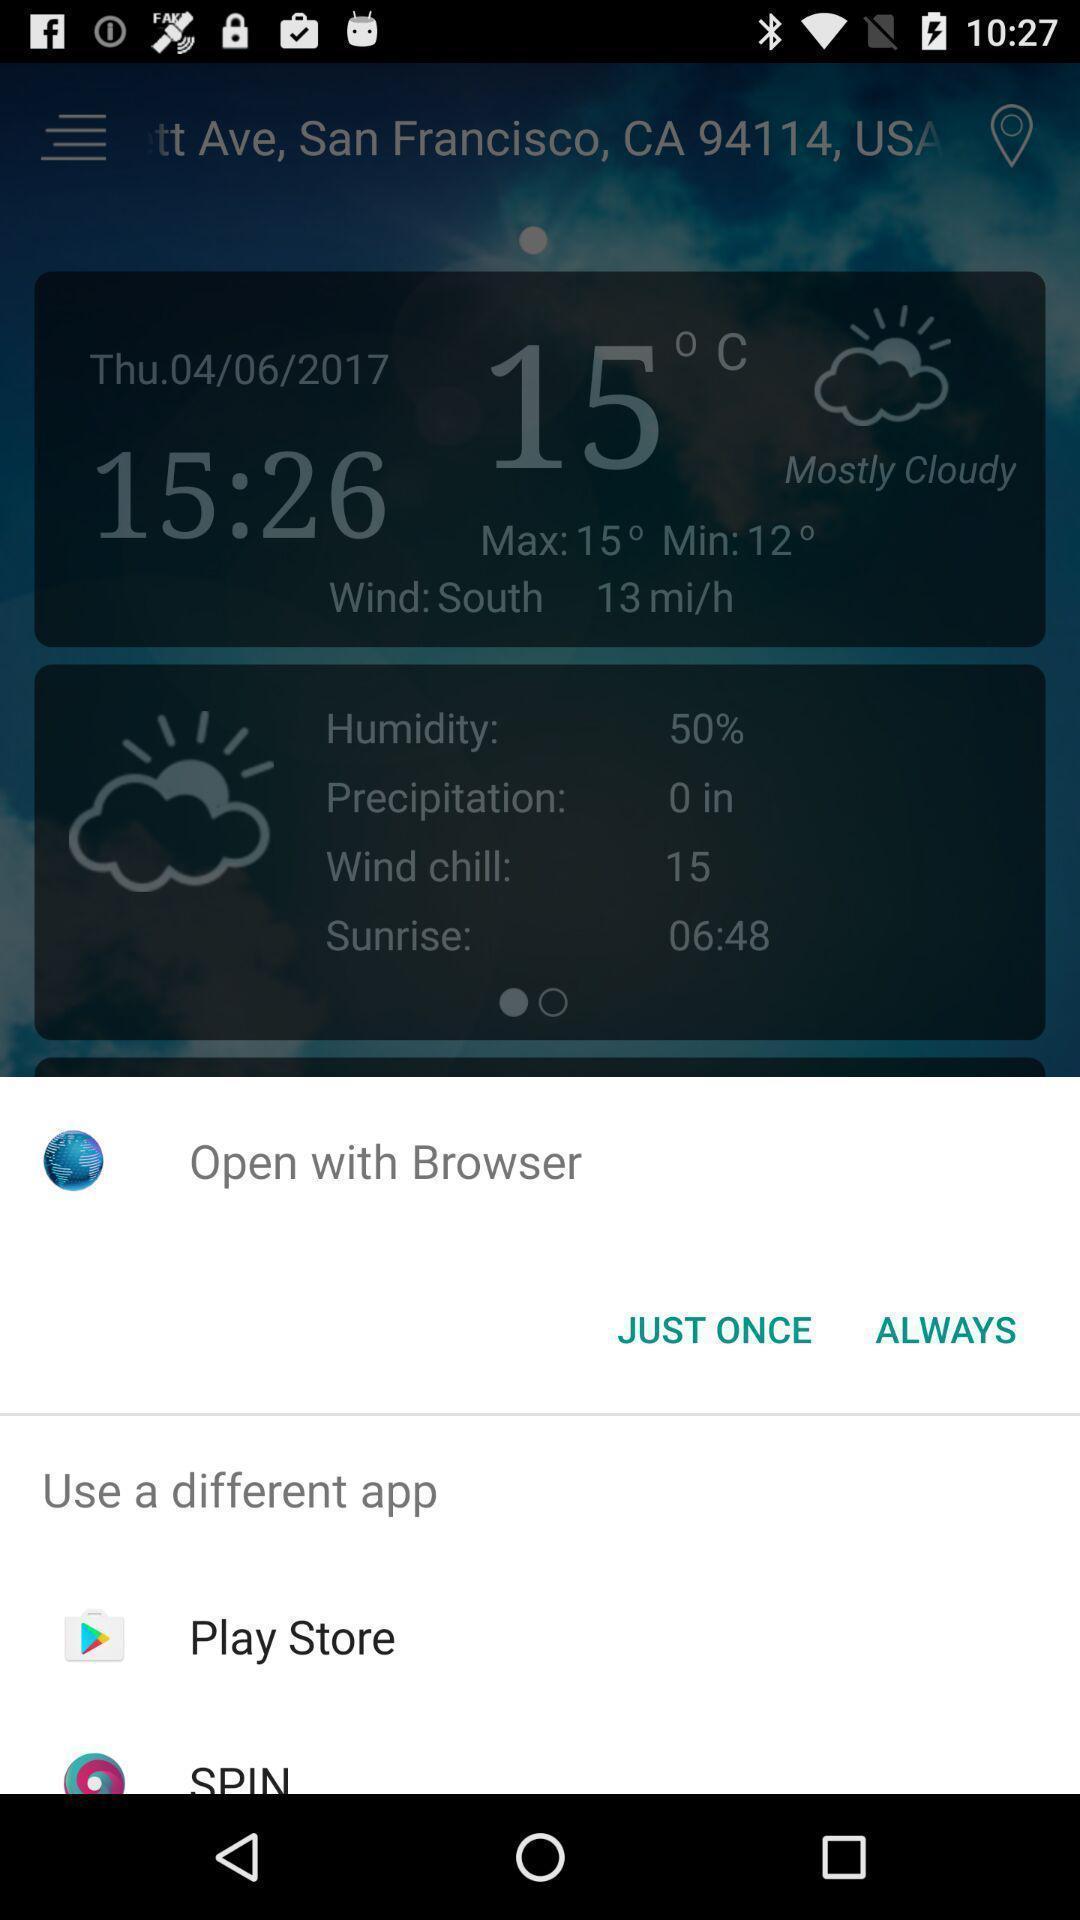Provide a description of this screenshot. Push up page showing app preference to open. 